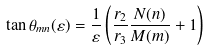<formula> <loc_0><loc_0><loc_500><loc_500>\tan \theta _ { m n } ( \varepsilon ) = \frac { 1 } { \varepsilon } \left ( \frac { r _ { 2 } } { r _ { 3 } } \frac { N ( n ) } { M ( m ) } + 1 \right )</formula> 